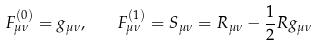Convert formula to latex. <formula><loc_0><loc_0><loc_500><loc_500>F _ { \mu \nu } ^ { ( 0 ) } = g _ { \mu \nu } , \quad F _ { \mu \nu } ^ { ( 1 ) } = S _ { \mu \nu } = R _ { \mu \nu } - \frac { 1 } { 2 } R g _ { \mu \nu }</formula> 